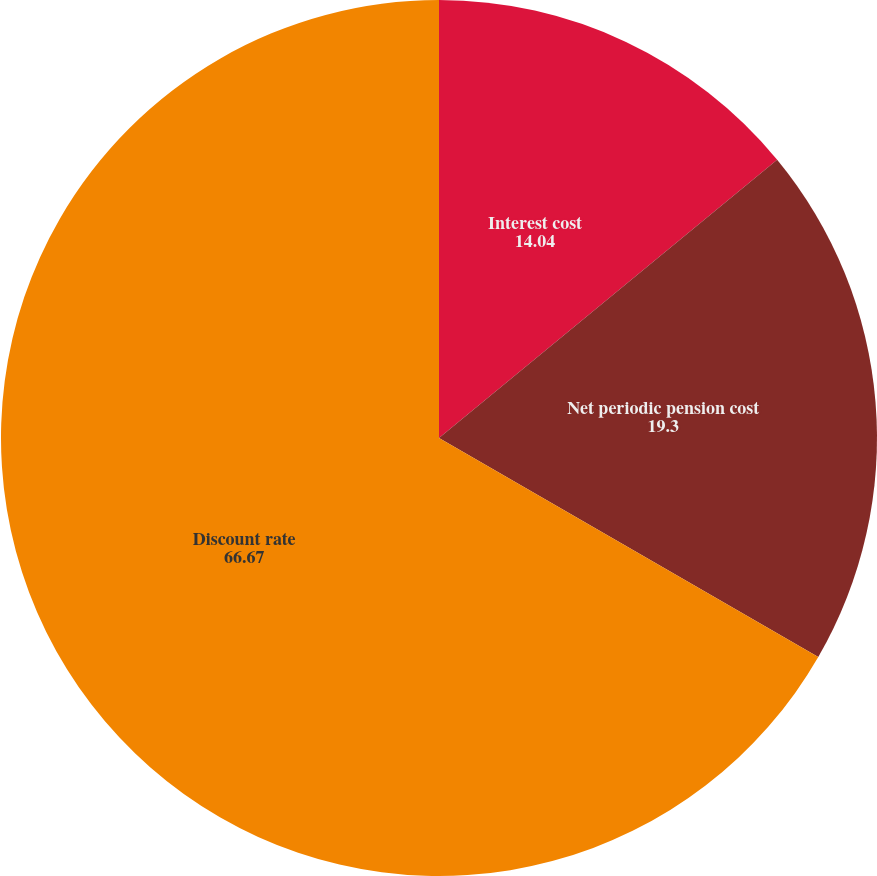<chart> <loc_0><loc_0><loc_500><loc_500><pie_chart><fcel>Interest cost<fcel>Net periodic pension cost<fcel>Discount rate<nl><fcel>14.04%<fcel>19.3%<fcel>66.67%<nl></chart> 